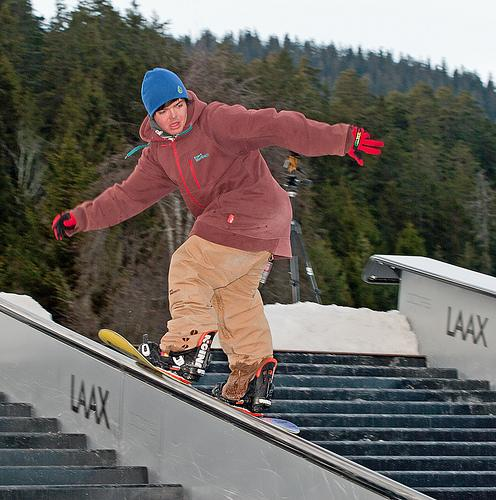List the main components of the image, including the person, the action, and the surrounding features. Boy, snowboarding on ledge, red and brown coat, blue cap, trees, stairs covered in snow, and tripod Mention the scene taking place in the image, focusing on the primary figure and their action. The scene shows a boy wearing a brown coat and blue cap, snowboarding on a ledge with a snowboard beneath him. Describe the main person featured in the image, their clothing, and the primary action taking place. A boy in a brown coat, blue cap, and red glove is snowboarding on a ledge amid a snowy landscape. Write a brief description of the person's outfit and their primary action. Boy wearing a brown coat, blue wool cap, red glove, and black boot is snowboarding on a ledge. Mention the essential elements of the image, including the subject, his appearance, and his activity. Snowboarder, blue wool cap, red glove, brown coat, sliding down a ledge on a snowboard. Provide a concise description of the person's outfit and the environment they're in while performing their action. Boy in blue cap, red glove, and brown coat snowboarding a ledge, with trees and snow-covered stairs in the background. Write a description of the central figure, their attire, and the primary activity taking place in the image. A snowboarder wearing a blue wool cap, red glove, and brown coat is seen sliding down a ledge on his snowboard. Identify the person's primary activity in the picture and the object they're using. A boy is snowboarding on a ledge using a snowboard. Write a short description of the setting and the primary action being carried out by the main person in the image. The setting includes a snowy landscape, trees, and stairs, with a boy snowboarding on a ledge as the primary action. Briefly summarize the primary focus of the image, stating the subject, their attire, and their activity. The image features a snowboarder in a brown coat, blue cap, and red glove, sliding down a ledge on a snowboard. 